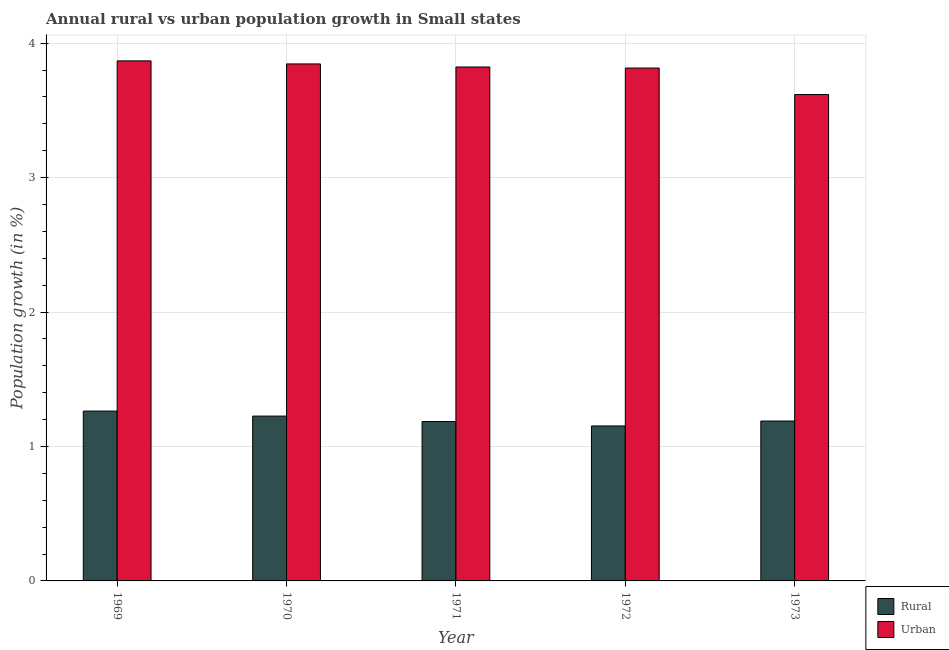How many different coloured bars are there?
Give a very brief answer. 2. Are the number of bars on each tick of the X-axis equal?
Give a very brief answer. Yes. How many bars are there on the 4th tick from the left?
Ensure brevity in your answer.  2. How many bars are there on the 5th tick from the right?
Make the answer very short. 2. What is the label of the 1st group of bars from the left?
Offer a very short reply. 1969. What is the rural population growth in 1971?
Your response must be concise. 1.19. Across all years, what is the maximum rural population growth?
Your response must be concise. 1.26. Across all years, what is the minimum rural population growth?
Offer a terse response. 1.15. In which year was the rural population growth maximum?
Provide a short and direct response. 1969. In which year was the rural population growth minimum?
Keep it short and to the point. 1972. What is the total urban population growth in the graph?
Ensure brevity in your answer.  18.97. What is the difference between the urban population growth in 1969 and that in 1973?
Offer a very short reply. 0.25. What is the difference between the rural population growth in 1972 and the urban population growth in 1969?
Offer a very short reply. -0.11. What is the average urban population growth per year?
Keep it short and to the point. 3.79. What is the ratio of the urban population growth in 1972 to that in 1973?
Keep it short and to the point. 1.05. Is the urban population growth in 1972 less than that in 1973?
Provide a short and direct response. No. What is the difference between the highest and the second highest urban population growth?
Give a very brief answer. 0.02. What is the difference between the highest and the lowest urban population growth?
Ensure brevity in your answer.  0.25. Is the sum of the rural population growth in 1970 and 1972 greater than the maximum urban population growth across all years?
Ensure brevity in your answer.  Yes. What does the 2nd bar from the left in 1969 represents?
Provide a succinct answer. Urban . What does the 1st bar from the right in 1972 represents?
Offer a terse response. Urban . Are all the bars in the graph horizontal?
Ensure brevity in your answer.  No. What is the difference between two consecutive major ticks on the Y-axis?
Provide a short and direct response. 1. Are the values on the major ticks of Y-axis written in scientific E-notation?
Offer a very short reply. No. Does the graph contain any zero values?
Keep it short and to the point. No. Does the graph contain grids?
Make the answer very short. Yes. What is the title of the graph?
Your response must be concise. Annual rural vs urban population growth in Small states. Does "Male labor force" appear as one of the legend labels in the graph?
Give a very brief answer. No. What is the label or title of the X-axis?
Your answer should be compact. Year. What is the label or title of the Y-axis?
Provide a short and direct response. Population growth (in %). What is the Population growth (in %) in Rural in 1969?
Provide a succinct answer. 1.26. What is the Population growth (in %) of Urban  in 1969?
Keep it short and to the point. 3.87. What is the Population growth (in %) in Rural in 1970?
Give a very brief answer. 1.23. What is the Population growth (in %) in Urban  in 1970?
Keep it short and to the point. 3.85. What is the Population growth (in %) in Rural in 1971?
Your answer should be compact. 1.19. What is the Population growth (in %) of Urban  in 1971?
Your answer should be compact. 3.82. What is the Population growth (in %) in Rural in 1972?
Your answer should be compact. 1.15. What is the Population growth (in %) of Urban  in 1972?
Ensure brevity in your answer.  3.81. What is the Population growth (in %) in Rural in 1973?
Provide a succinct answer. 1.19. What is the Population growth (in %) in Urban  in 1973?
Make the answer very short. 3.62. Across all years, what is the maximum Population growth (in %) of Rural?
Give a very brief answer. 1.26. Across all years, what is the maximum Population growth (in %) in Urban ?
Offer a terse response. 3.87. Across all years, what is the minimum Population growth (in %) in Rural?
Your answer should be compact. 1.15. Across all years, what is the minimum Population growth (in %) of Urban ?
Provide a short and direct response. 3.62. What is the total Population growth (in %) in Rural in the graph?
Offer a very short reply. 6.02. What is the total Population growth (in %) of Urban  in the graph?
Your answer should be very brief. 18.97. What is the difference between the Population growth (in %) of Rural in 1969 and that in 1970?
Your answer should be compact. 0.04. What is the difference between the Population growth (in %) of Urban  in 1969 and that in 1970?
Your response must be concise. 0.02. What is the difference between the Population growth (in %) in Rural in 1969 and that in 1971?
Provide a succinct answer. 0.08. What is the difference between the Population growth (in %) of Urban  in 1969 and that in 1971?
Offer a very short reply. 0.05. What is the difference between the Population growth (in %) in Rural in 1969 and that in 1972?
Ensure brevity in your answer.  0.11. What is the difference between the Population growth (in %) of Urban  in 1969 and that in 1972?
Your response must be concise. 0.05. What is the difference between the Population growth (in %) in Rural in 1969 and that in 1973?
Ensure brevity in your answer.  0.07. What is the difference between the Population growth (in %) in Urban  in 1969 and that in 1973?
Your response must be concise. 0.25. What is the difference between the Population growth (in %) of Rural in 1970 and that in 1971?
Keep it short and to the point. 0.04. What is the difference between the Population growth (in %) of Urban  in 1970 and that in 1971?
Make the answer very short. 0.02. What is the difference between the Population growth (in %) of Rural in 1970 and that in 1972?
Offer a very short reply. 0.07. What is the difference between the Population growth (in %) in Urban  in 1970 and that in 1972?
Keep it short and to the point. 0.03. What is the difference between the Population growth (in %) in Rural in 1970 and that in 1973?
Keep it short and to the point. 0.04. What is the difference between the Population growth (in %) in Urban  in 1970 and that in 1973?
Ensure brevity in your answer.  0.23. What is the difference between the Population growth (in %) of Rural in 1971 and that in 1972?
Give a very brief answer. 0.03. What is the difference between the Population growth (in %) of Urban  in 1971 and that in 1972?
Offer a very short reply. 0.01. What is the difference between the Population growth (in %) of Rural in 1971 and that in 1973?
Provide a short and direct response. -0. What is the difference between the Population growth (in %) of Urban  in 1971 and that in 1973?
Your answer should be compact. 0.2. What is the difference between the Population growth (in %) in Rural in 1972 and that in 1973?
Your response must be concise. -0.04. What is the difference between the Population growth (in %) of Urban  in 1972 and that in 1973?
Provide a succinct answer. 0.2. What is the difference between the Population growth (in %) in Rural in 1969 and the Population growth (in %) in Urban  in 1970?
Offer a very short reply. -2.58. What is the difference between the Population growth (in %) of Rural in 1969 and the Population growth (in %) of Urban  in 1971?
Keep it short and to the point. -2.56. What is the difference between the Population growth (in %) in Rural in 1969 and the Population growth (in %) in Urban  in 1972?
Your answer should be compact. -2.55. What is the difference between the Population growth (in %) of Rural in 1969 and the Population growth (in %) of Urban  in 1973?
Keep it short and to the point. -2.35. What is the difference between the Population growth (in %) of Rural in 1970 and the Population growth (in %) of Urban  in 1971?
Your answer should be compact. -2.6. What is the difference between the Population growth (in %) of Rural in 1970 and the Population growth (in %) of Urban  in 1972?
Keep it short and to the point. -2.59. What is the difference between the Population growth (in %) of Rural in 1970 and the Population growth (in %) of Urban  in 1973?
Ensure brevity in your answer.  -2.39. What is the difference between the Population growth (in %) in Rural in 1971 and the Population growth (in %) in Urban  in 1972?
Give a very brief answer. -2.63. What is the difference between the Population growth (in %) of Rural in 1971 and the Population growth (in %) of Urban  in 1973?
Your response must be concise. -2.43. What is the difference between the Population growth (in %) in Rural in 1972 and the Population growth (in %) in Urban  in 1973?
Make the answer very short. -2.46. What is the average Population growth (in %) in Rural per year?
Keep it short and to the point. 1.2. What is the average Population growth (in %) in Urban  per year?
Your answer should be compact. 3.79. In the year 1969, what is the difference between the Population growth (in %) of Rural and Population growth (in %) of Urban ?
Provide a short and direct response. -2.6. In the year 1970, what is the difference between the Population growth (in %) in Rural and Population growth (in %) in Urban ?
Provide a succinct answer. -2.62. In the year 1971, what is the difference between the Population growth (in %) of Rural and Population growth (in %) of Urban ?
Provide a short and direct response. -2.64. In the year 1972, what is the difference between the Population growth (in %) in Rural and Population growth (in %) in Urban ?
Give a very brief answer. -2.66. In the year 1973, what is the difference between the Population growth (in %) of Rural and Population growth (in %) of Urban ?
Offer a terse response. -2.43. What is the ratio of the Population growth (in %) in Rural in 1969 to that in 1970?
Give a very brief answer. 1.03. What is the ratio of the Population growth (in %) in Urban  in 1969 to that in 1970?
Provide a short and direct response. 1.01. What is the ratio of the Population growth (in %) in Rural in 1969 to that in 1971?
Your answer should be compact. 1.07. What is the ratio of the Population growth (in %) of Urban  in 1969 to that in 1971?
Keep it short and to the point. 1.01. What is the ratio of the Population growth (in %) in Rural in 1969 to that in 1972?
Offer a terse response. 1.1. What is the ratio of the Population growth (in %) of Urban  in 1969 to that in 1972?
Ensure brevity in your answer.  1.01. What is the ratio of the Population growth (in %) in Rural in 1969 to that in 1973?
Your answer should be very brief. 1.06. What is the ratio of the Population growth (in %) of Urban  in 1969 to that in 1973?
Offer a terse response. 1.07. What is the ratio of the Population growth (in %) in Rural in 1970 to that in 1971?
Give a very brief answer. 1.03. What is the ratio of the Population growth (in %) in Urban  in 1970 to that in 1971?
Offer a very short reply. 1.01. What is the ratio of the Population growth (in %) of Rural in 1970 to that in 1972?
Your answer should be very brief. 1.06. What is the ratio of the Population growth (in %) in Rural in 1970 to that in 1973?
Offer a terse response. 1.03. What is the ratio of the Population growth (in %) in Urban  in 1970 to that in 1973?
Your answer should be very brief. 1.06. What is the ratio of the Population growth (in %) in Rural in 1971 to that in 1972?
Offer a terse response. 1.03. What is the ratio of the Population growth (in %) of Urban  in 1971 to that in 1973?
Give a very brief answer. 1.06. What is the ratio of the Population growth (in %) in Rural in 1972 to that in 1973?
Give a very brief answer. 0.97. What is the ratio of the Population growth (in %) of Urban  in 1972 to that in 1973?
Your response must be concise. 1.05. What is the difference between the highest and the second highest Population growth (in %) of Rural?
Offer a terse response. 0.04. What is the difference between the highest and the second highest Population growth (in %) in Urban ?
Your response must be concise. 0.02. What is the difference between the highest and the lowest Population growth (in %) of Rural?
Keep it short and to the point. 0.11. What is the difference between the highest and the lowest Population growth (in %) of Urban ?
Offer a terse response. 0.25. 